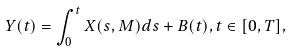<formula> <loc_0><loc_0><loc_500><loc_500>Y ( t ) = \int _ { 0 } ^ { t } X ( s , M ) d s + B ( t ) , t \in [ 0 , T ] ,</formula> 